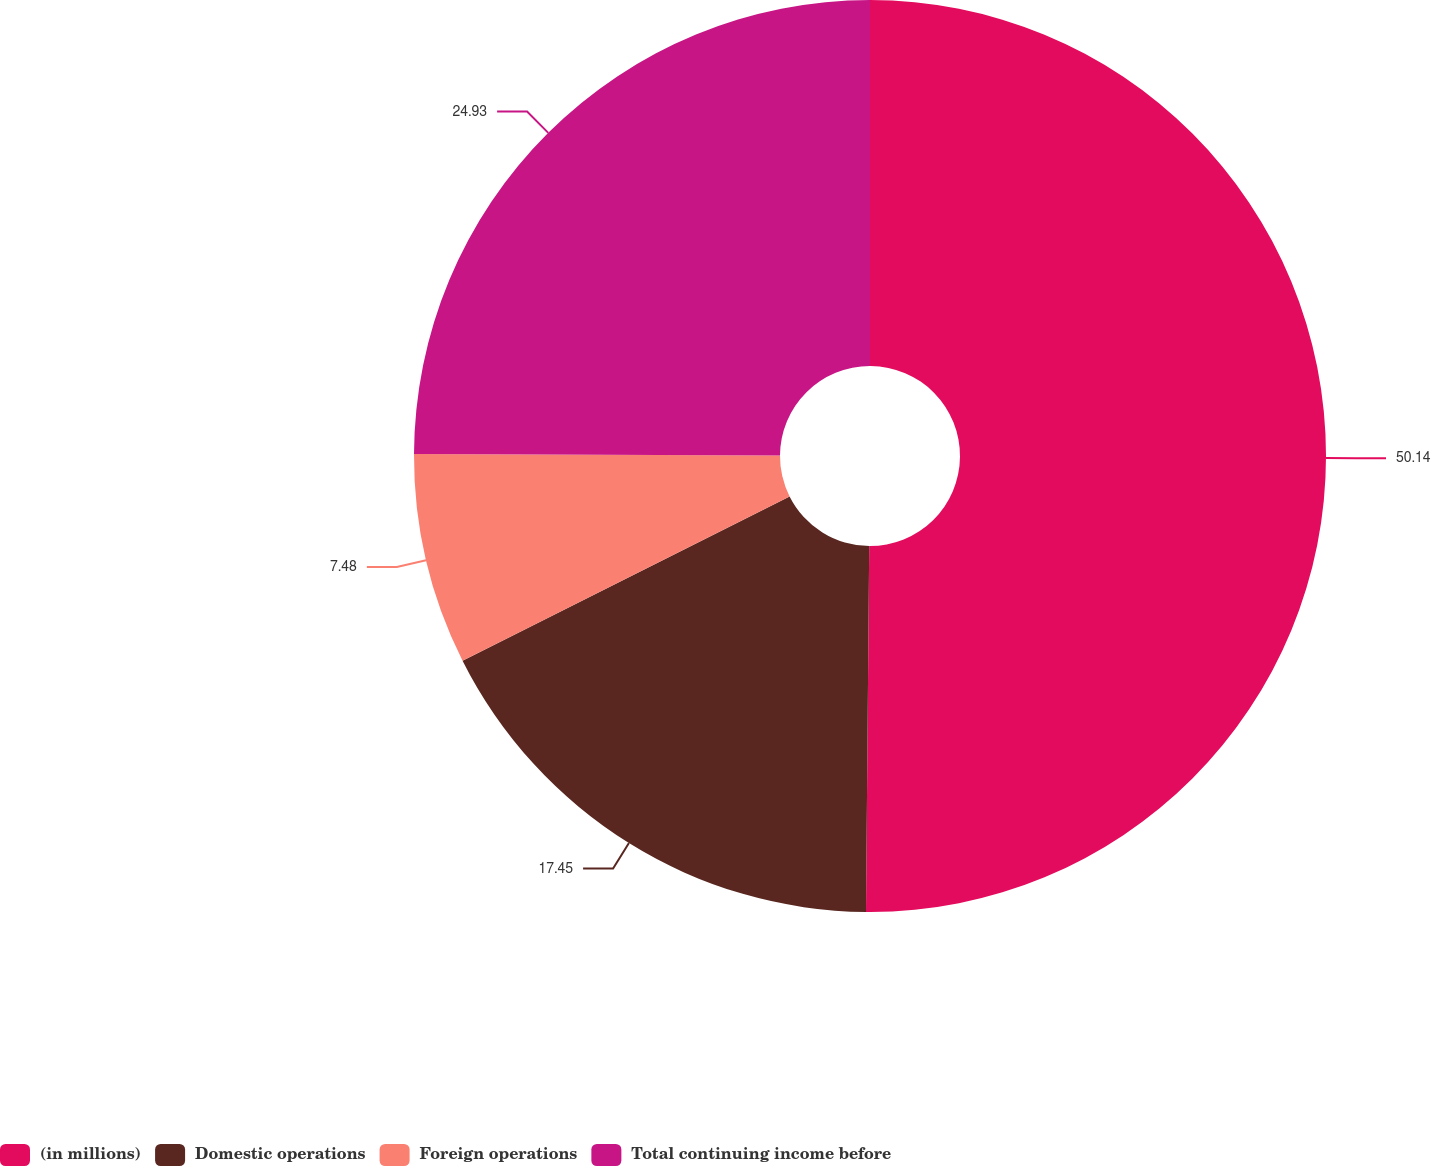<chart> <loc_0><loc_0><loc_500><loc_500><pie_chart><fcel>(in millions)<fcel>Domestic operations<fcel>Foreign operations<fcel>Total continuing income before<nl><fcel>50.14%<fcel>17.45%<fcel>7.48%<fcel>24.93%<nl></chart> 